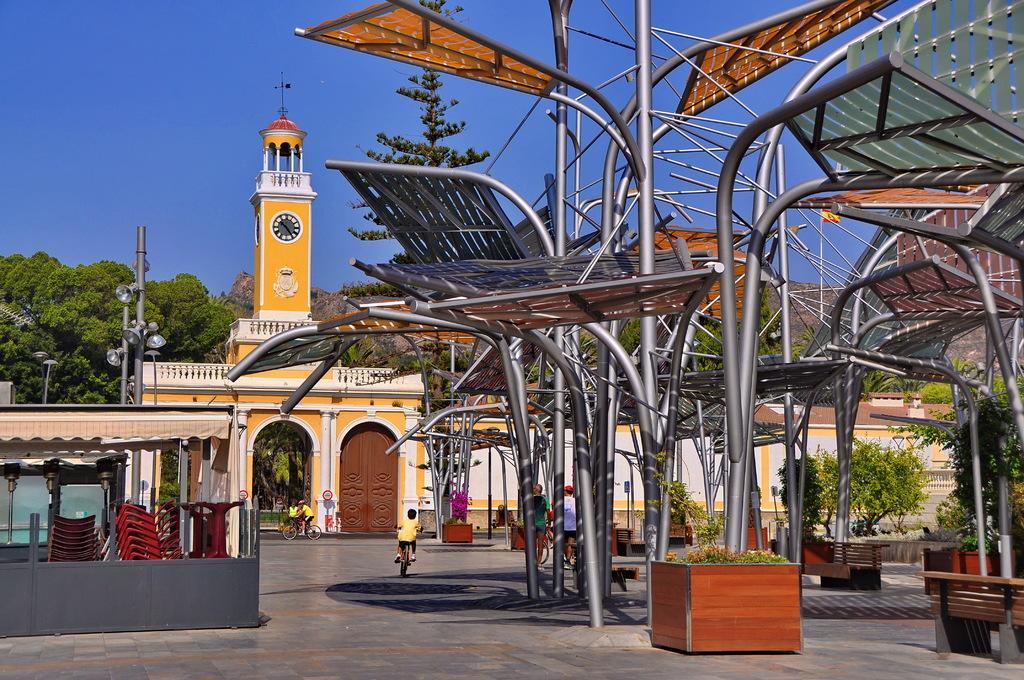In one or two sentences, can you explain what this image depicts? In this image I can see metal rods and on the road there are few persons riding on bicycles , there are some chairs , flower pot and benches kept on it ,at the top there is the sky and clock tower , entrance gate ,the wall and poles visible in the middle. 